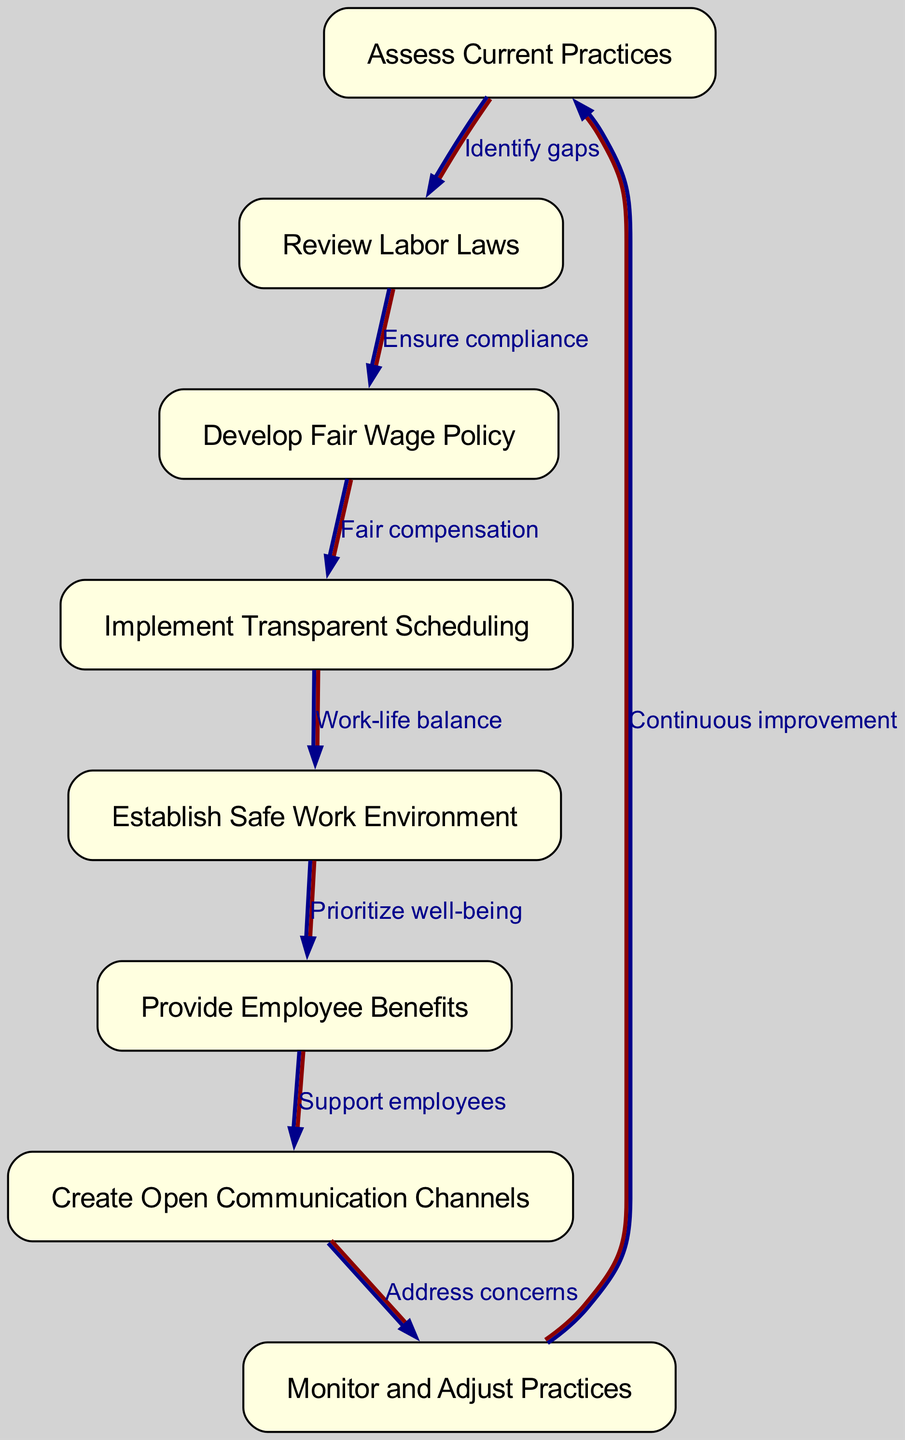What is the first step in implementing ethical labor practices? The first step in the process is represented by the first box in the diagram, which is "Assess Current Practices." Therefore, the flow starts here before moving on to other steps.
Answer: Assess Current Practices What is the last step in the diagram? The last step is indicated by the flow returning to "Assess Current Practices." This shows a circular process of continuous improvement, reinforcing the need for ongoing evaluation of practices.
Answer: Assess Current Practices How many nodes are present in the diagram? By counting the number of distinct boxes in the diagram, we find there are eight nodes that represent different steps in the implementation process.
Answer: 8 What two nodes are directly connected by the "Ensure compliance" edge? The edge labeled "Ensure compliance" connects the node "Review Labor Laws" to the node "Develop Fair Wage Policy." This conveys a direct relationship where reviewing laws is essential before creating a wage policy.
Answer: Review Labor Laws, Develop Fair Wage Policy Which node focuses on establishing a work environment? The node dedicated to creating a safe work environment is "Establish Safe Work Environment." This is crucial in the overall process of implementing ethical labor practices.
Answer: Establish Safe Work Environment What is the relationship between "Provide Employee Benefits" and "Create Open Communication Channels"? The relationship is that "Provide Employee Benefits" directly leads to "Create Open Communication Channels," highlighted by the flow indicating that supporting employees through benefits encourages open dialogue.
Answer: Support employees How many edges are there in the diagram? The number of edges can be determined by counting the connections or lines that link the nodes throughout the entire diagram. Upon review, there are seven edges.
Answer: 7 What concept does the arrow from "Monitor and Adjust Practices" to "Assess Current Practices" illustrate? This arrow symbolizes the concept of continuous improvement, indicating that feedback and monitoring help to reassess and refine labor practices, thus completing the cycle.
Answer: Continuous improvement 